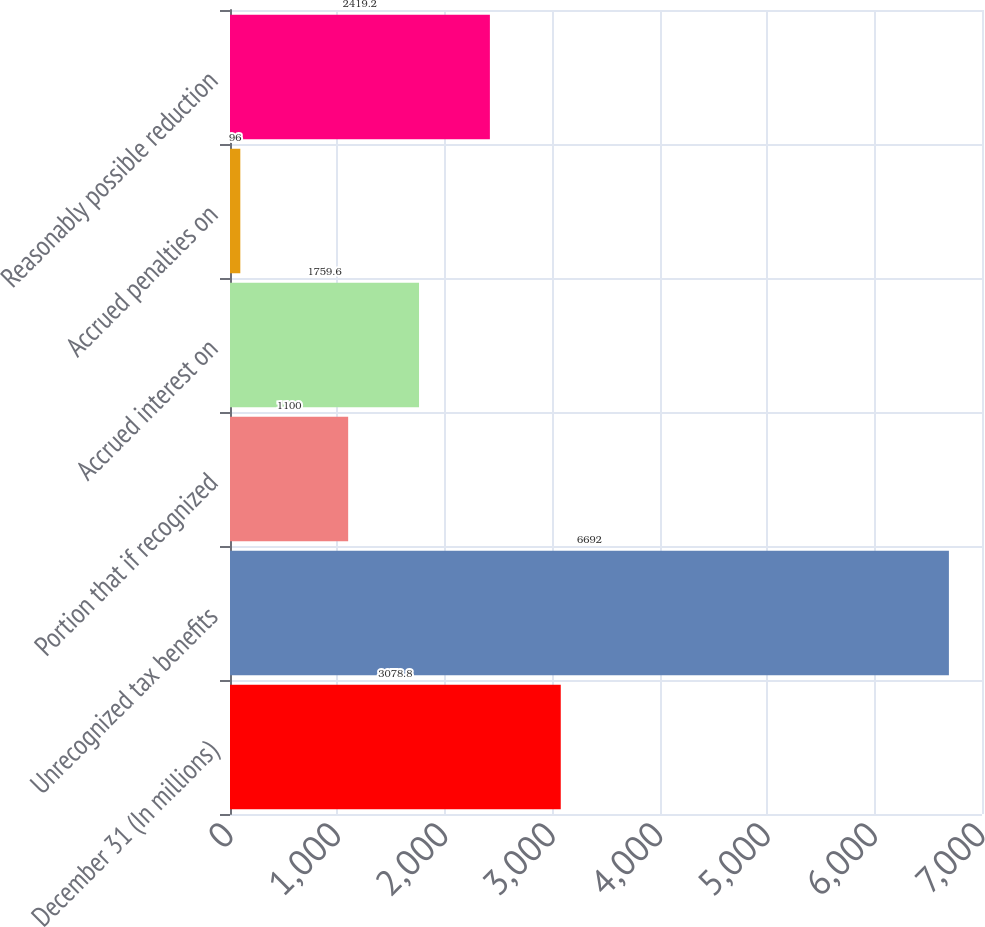Convert chart. <chart><loc_0><loc_0><loc_500><loc_500><bar_chart><fcel>December 31 (In millions)<fcel>Unrecognized tax benefits<fcel>Portion that if recognized<fcel>Accrued interest on<fcel>Accrued penalties on<fcel>Reasonably possible reduction<nl><fcel>3078.8<fcel>6692<fcel>1100<fcel>1759.6<fcel>96<fcel>2419.2<nl></chart> 